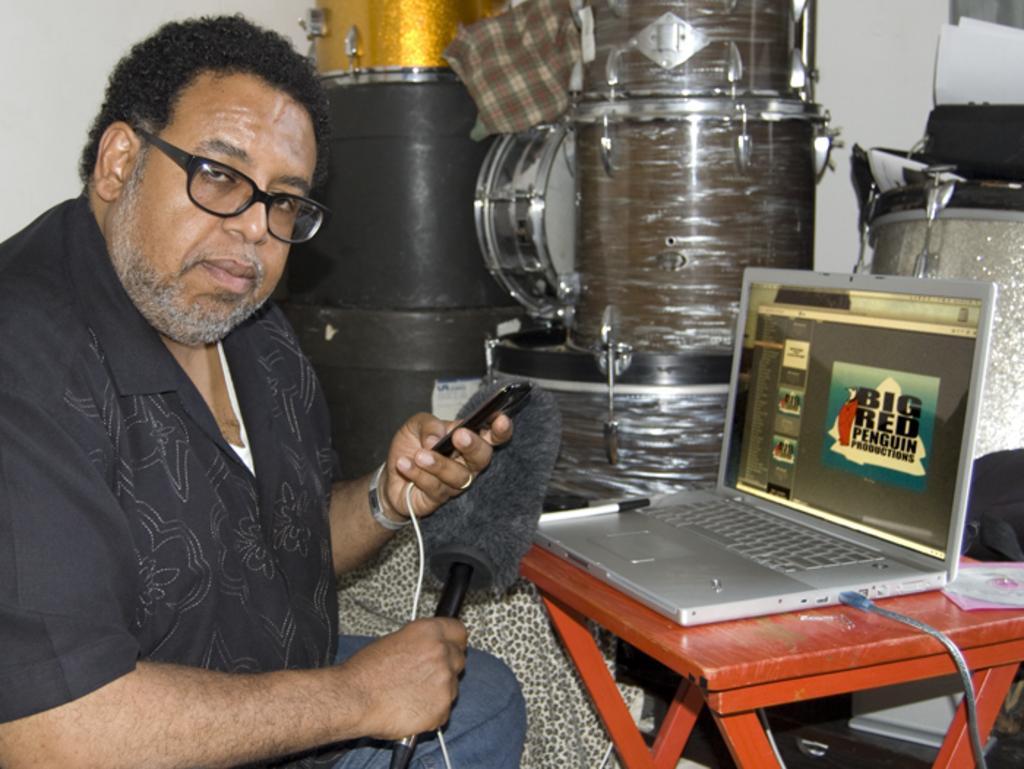Could you give a brief overview of what you see in this image? Here we can see a man. This man wore spectacles, holding a mobile and an object. On this table there is a laptop, CD and bag. Background there are musical instruments, papers and wall. On this laptop there is a pen. 